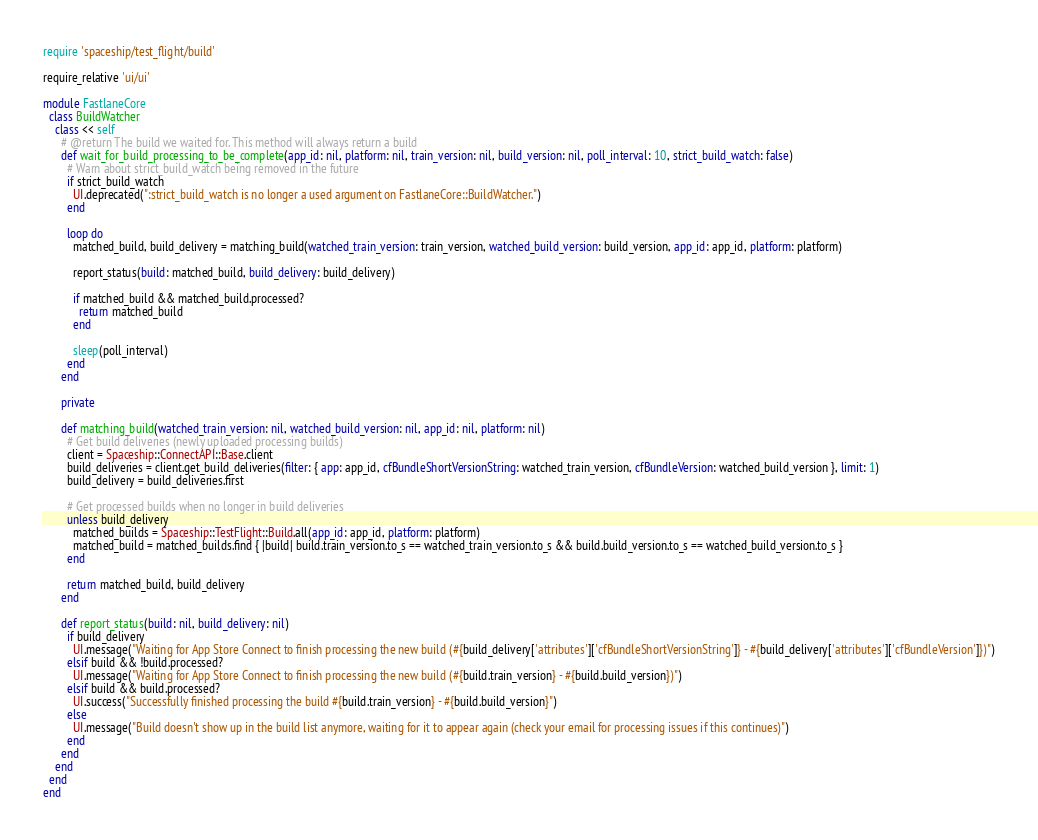Convert code to text. <code><loc_0><loc_0><loc_500><loc_500><_Ruby_>require 'spaceship/test_flight/build'

require_relative 'ui/ui'

module FastlaneCore
  class BuildWatcher
    class << self
      # @return The build we waited for. This method will always return a build
      def wait_for_build_processing_to_be_complete(app_id: nil, platform: nil, train_version: nil, build_version: nil, poll_interval: 10, strict_build_watch: false)
        # Warn about strict_build_watch being removed in the future
        if strict_build_watch
          UI.deprecated(":strict_build_watch is no longer a used argument on FastlaneCore::BuildWatcher.")
        end

        loop do
          matched_build, build_delivery = matching_build(watched_train_version: train_version, watched_build_version: build_version, app_id: app_id, platform: platform)

          report_status(build: matched_build, build_delivery: build_delivery)

          if matched_build && matched_build.processed?
            return matched_build
          end

          sleep(poll_interval)
        end
      end

      private

      def matching_build(watched_train_version: nil, watched_build_version: nil, app_id: nil, platform: nil)
        # Get build deliveries (newly uploaded processing builds)
        client = Spaceship::ConnectAPI::Base.client
        build_deliveries = client.get_build_deliveries(filter: { app: app_id, cfBundleShortVersionString: watched_train_version, cfBundleVersion: watched_build_version }, limit: 1)
        build_delivery = build_deliveries.first

        # Get processed builds when no longer in build deliveries
        unless build_delivery
          matched_builds = Spaceship::TestFlight::Build.all(app_id: app_id, platform: platform)
          matched_build = matched_builds.find { |build| build.train_version.to_s == watched_train_version.to_s && build.build_version.to_s == watched_build_version.to_s }
        end

        return matched_build, build_delivery
      end

      def report_status(build: nil, build_delivery: nil)
        if build_delivery
          UI.message("Waiting for App Store Connect to finish processing the new build (#{build_delivery['attributes']['cfBundleShortVersionString']} - #{build_delivery['attributes']['cfBundleVersion']})")
        elsif build && !build.processed?
          UI.message("Waiting for App Store Connect to finish processing the new build (#{build.train_version} - #{build.build_version})")
        elsif build && build.processed?
          UI.success("Successfully finished processing the build #{build.train_version} - #{build.build_version}")
        else
          UI.message("Build doesn't show up in the build list anymore, waiting for it to appear again (check your email for processing issues if this continues)")
        end
      end
    end
  end
end
</code> 